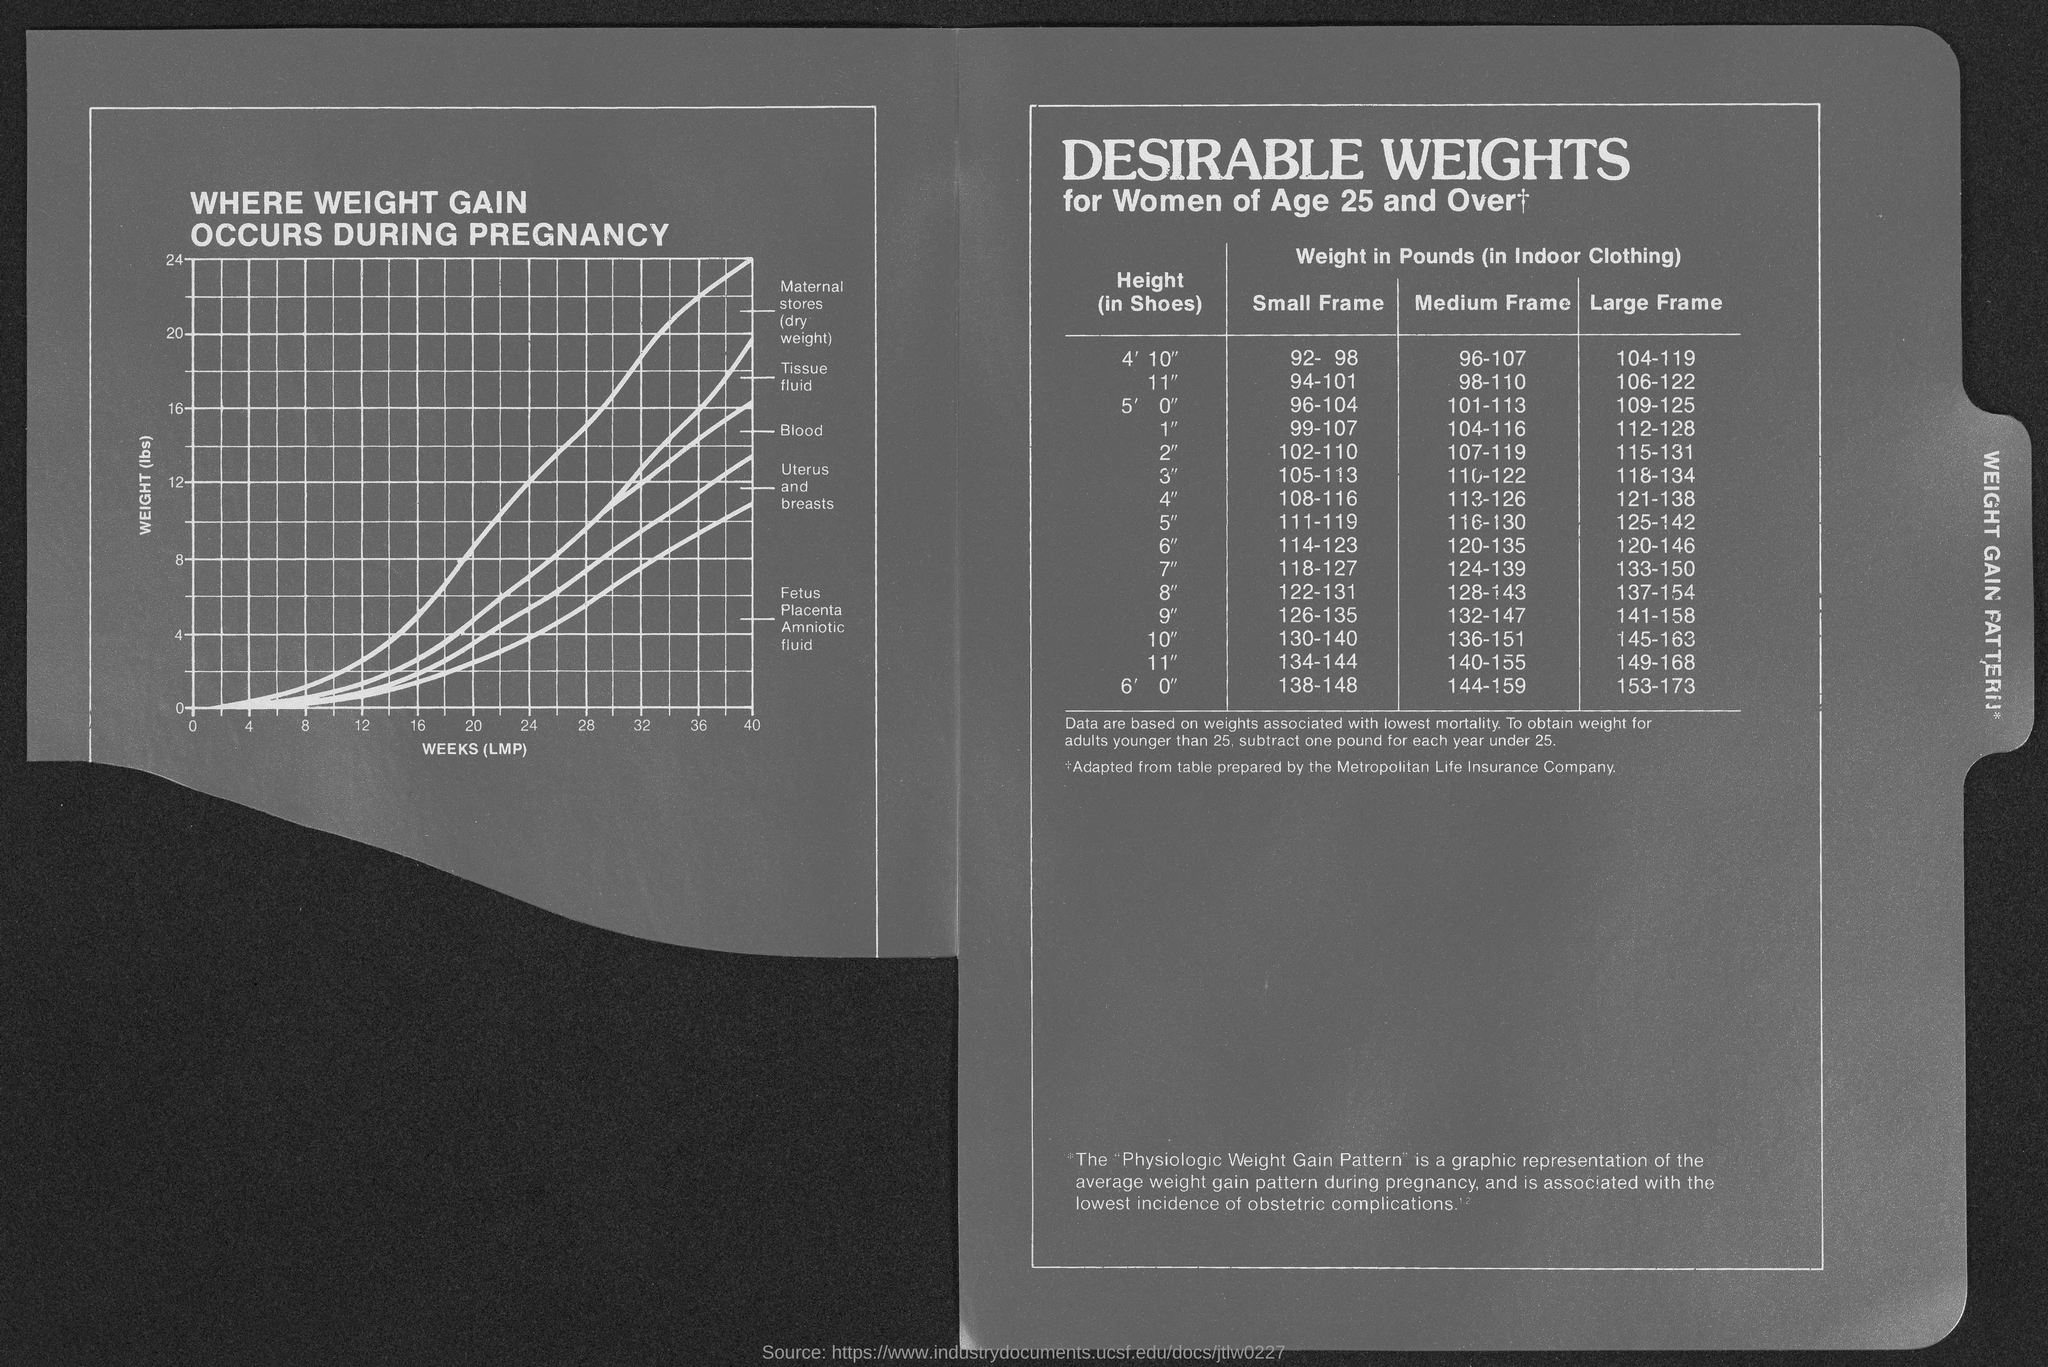What is the title of the graph?
Make the answer very short. WHERE WEIGHT GAIN OCCURS DURING PREGNANCY. What is the title of the table?
Give a very brief answer. Desirable weights for women of age 25 and over. What is on the x-axis of the graph?
Offer a very short reply. Weeks (LMP). What is on the y-axis of the graph?
Give a very brief answer. Weight (lbs). 